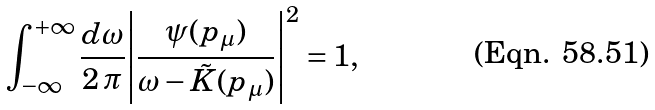Convert formula to latex. <formula><loc_0><loc_0><loc_500><loc_500>\int ^ { + \infty } _ { - \infty } \frac { d \omega } { 2 \, \pi } { \left | \frac { \psi ( p _ { \mu } ) } { \omega - \tilde { K } ( p _ { \mu } ) } \right | } ^ { 2 } = 1 ,</formula> 